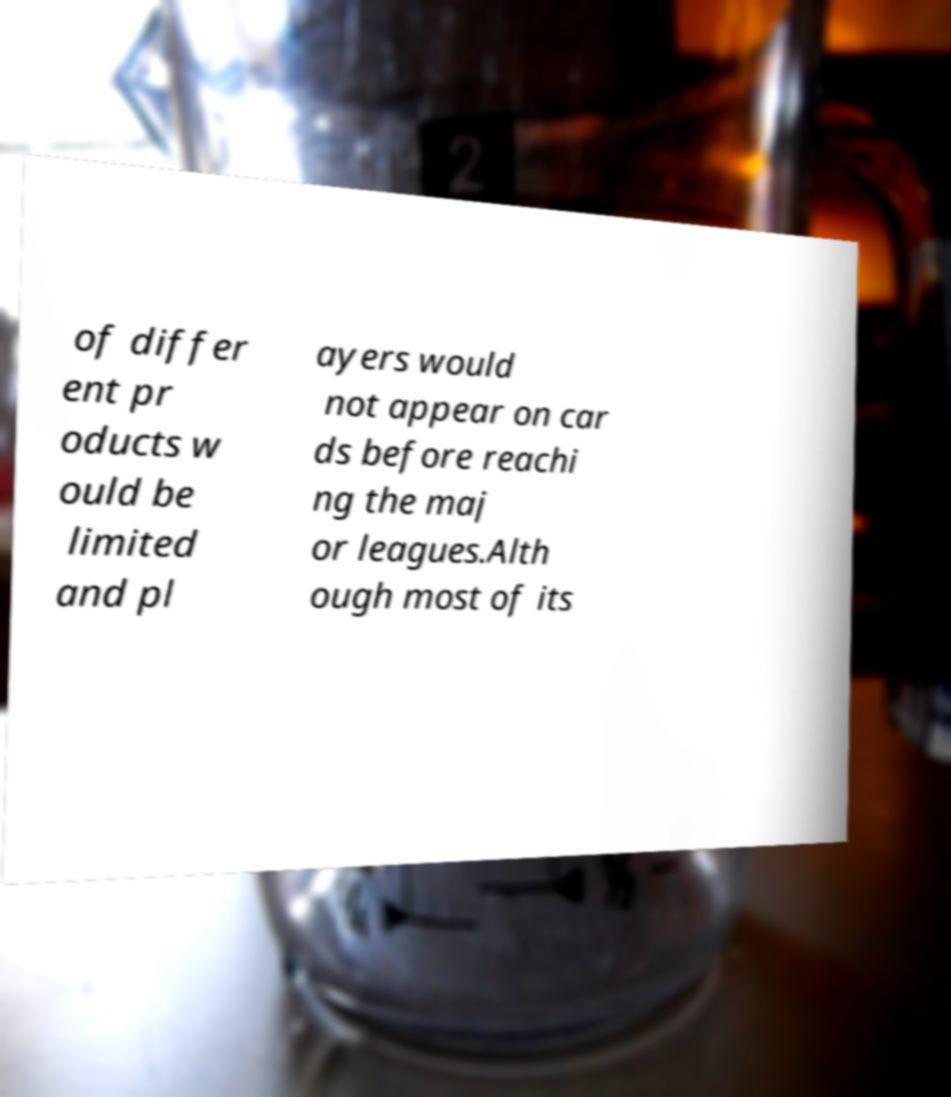Can you accurately transcribe the text from the provided image for me? of differ ent pr oducts w ould be limited and pl ayers would not appear on car ds before reachi ng the maj or leagues.Alth ough most of its 